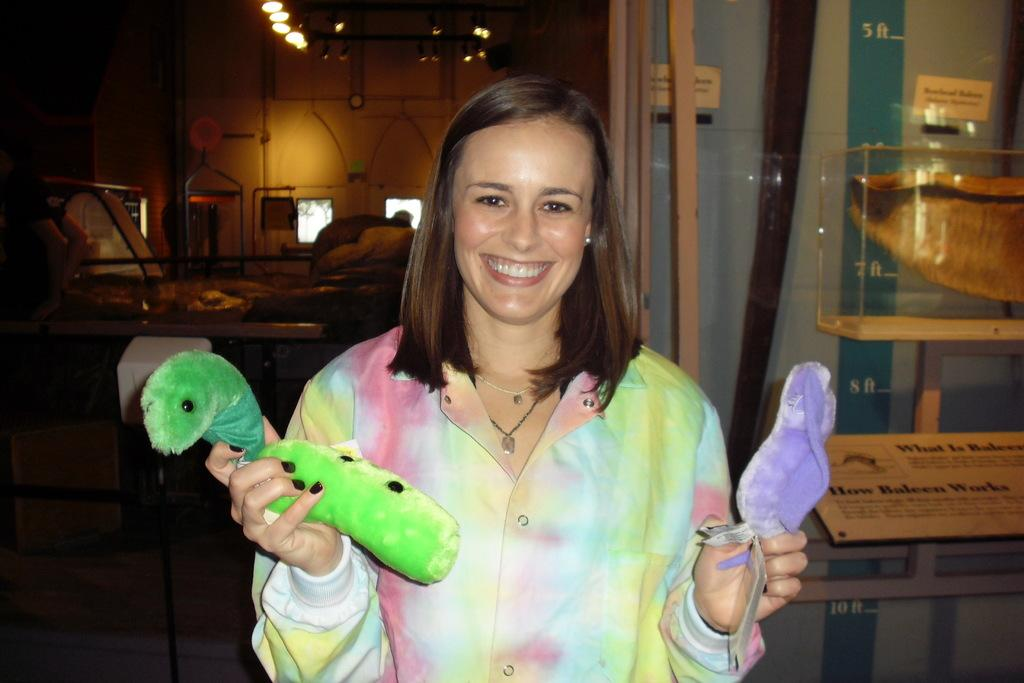Who or what is the main subject in the image? There is a person in the image. What else can be seen in the image besides the person? There are other objects in the image. Can you describe the background of the image? There is a wall, glass windows, lights, glass objects, a name board, and other objects in the background of the image. What type of locket is the person wearing in the image? There is no locket visible on the person in the image. How many cups can be seen in the image? There are no cups present in the image. 